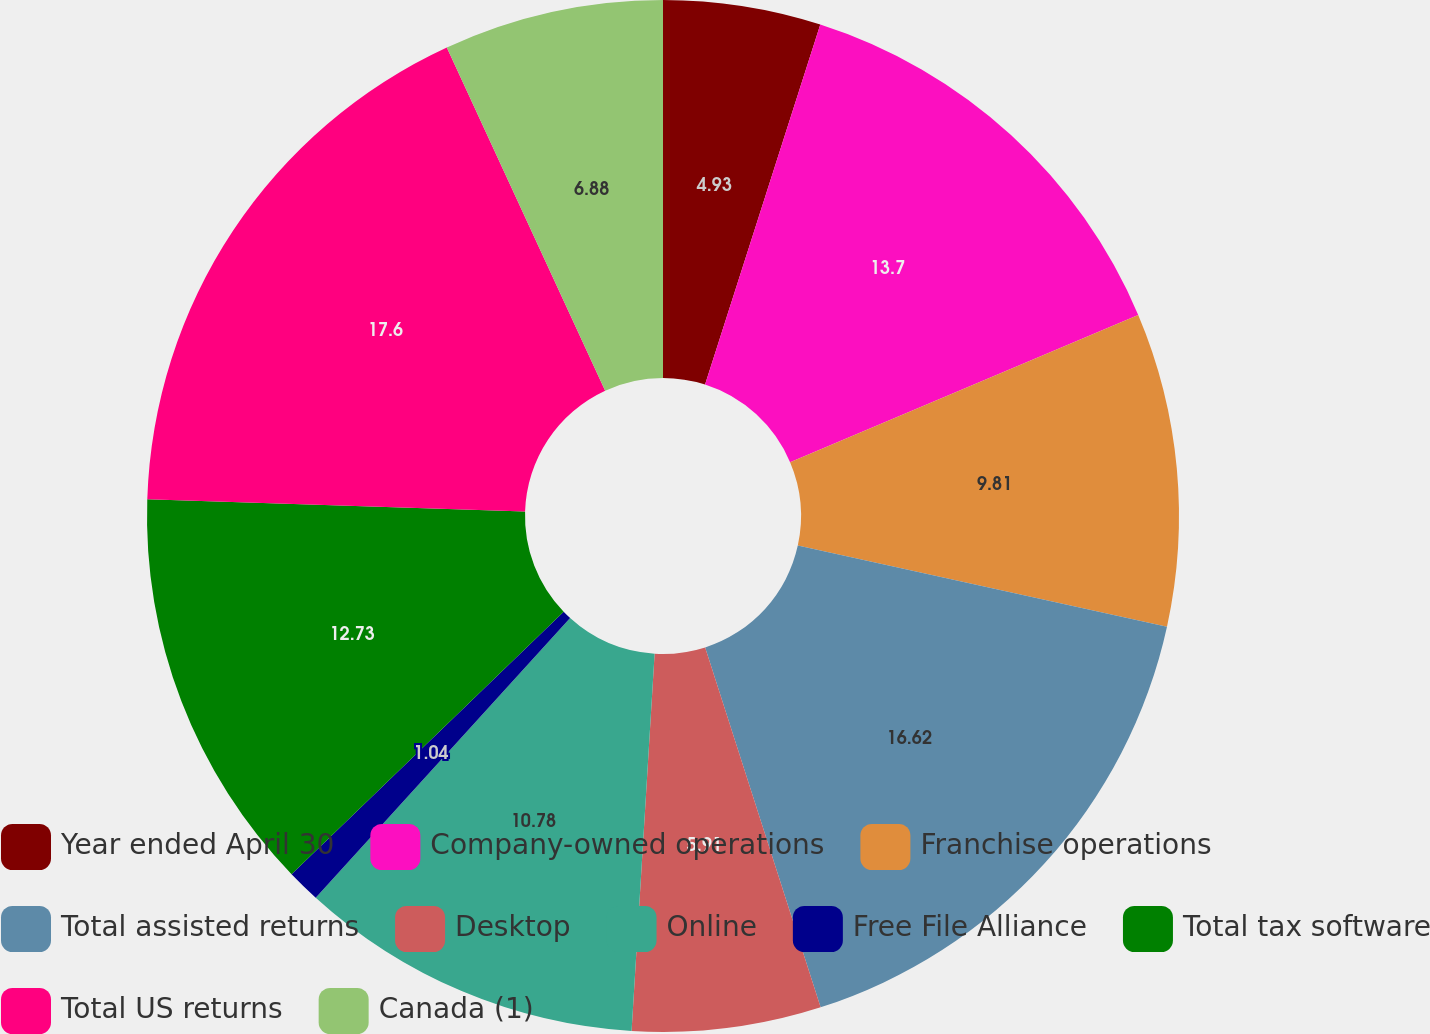Convert chart. <chart><loc_0><loc_0><loc_500><loc_500><pie_chart><fcel>Year ended April 30<fcel>Company-owned operations<fcel>Franchise operations<fcel>Total assisted returns<fcel>Desktop<fcel>Online<fcel>Free File Alliance<fcel>Total tax software<fcel>Total US returns<fcel>Canada (1)<nl><fcel>4.93%<fcel>13.7%<fcel>9.81%<fcel>16.62%<fcel>5.91%<fcel>10.78%<fcel>1.04%<fcel>12.73%<fcel>17.6%<fcel>6.88%<nl></chart> 